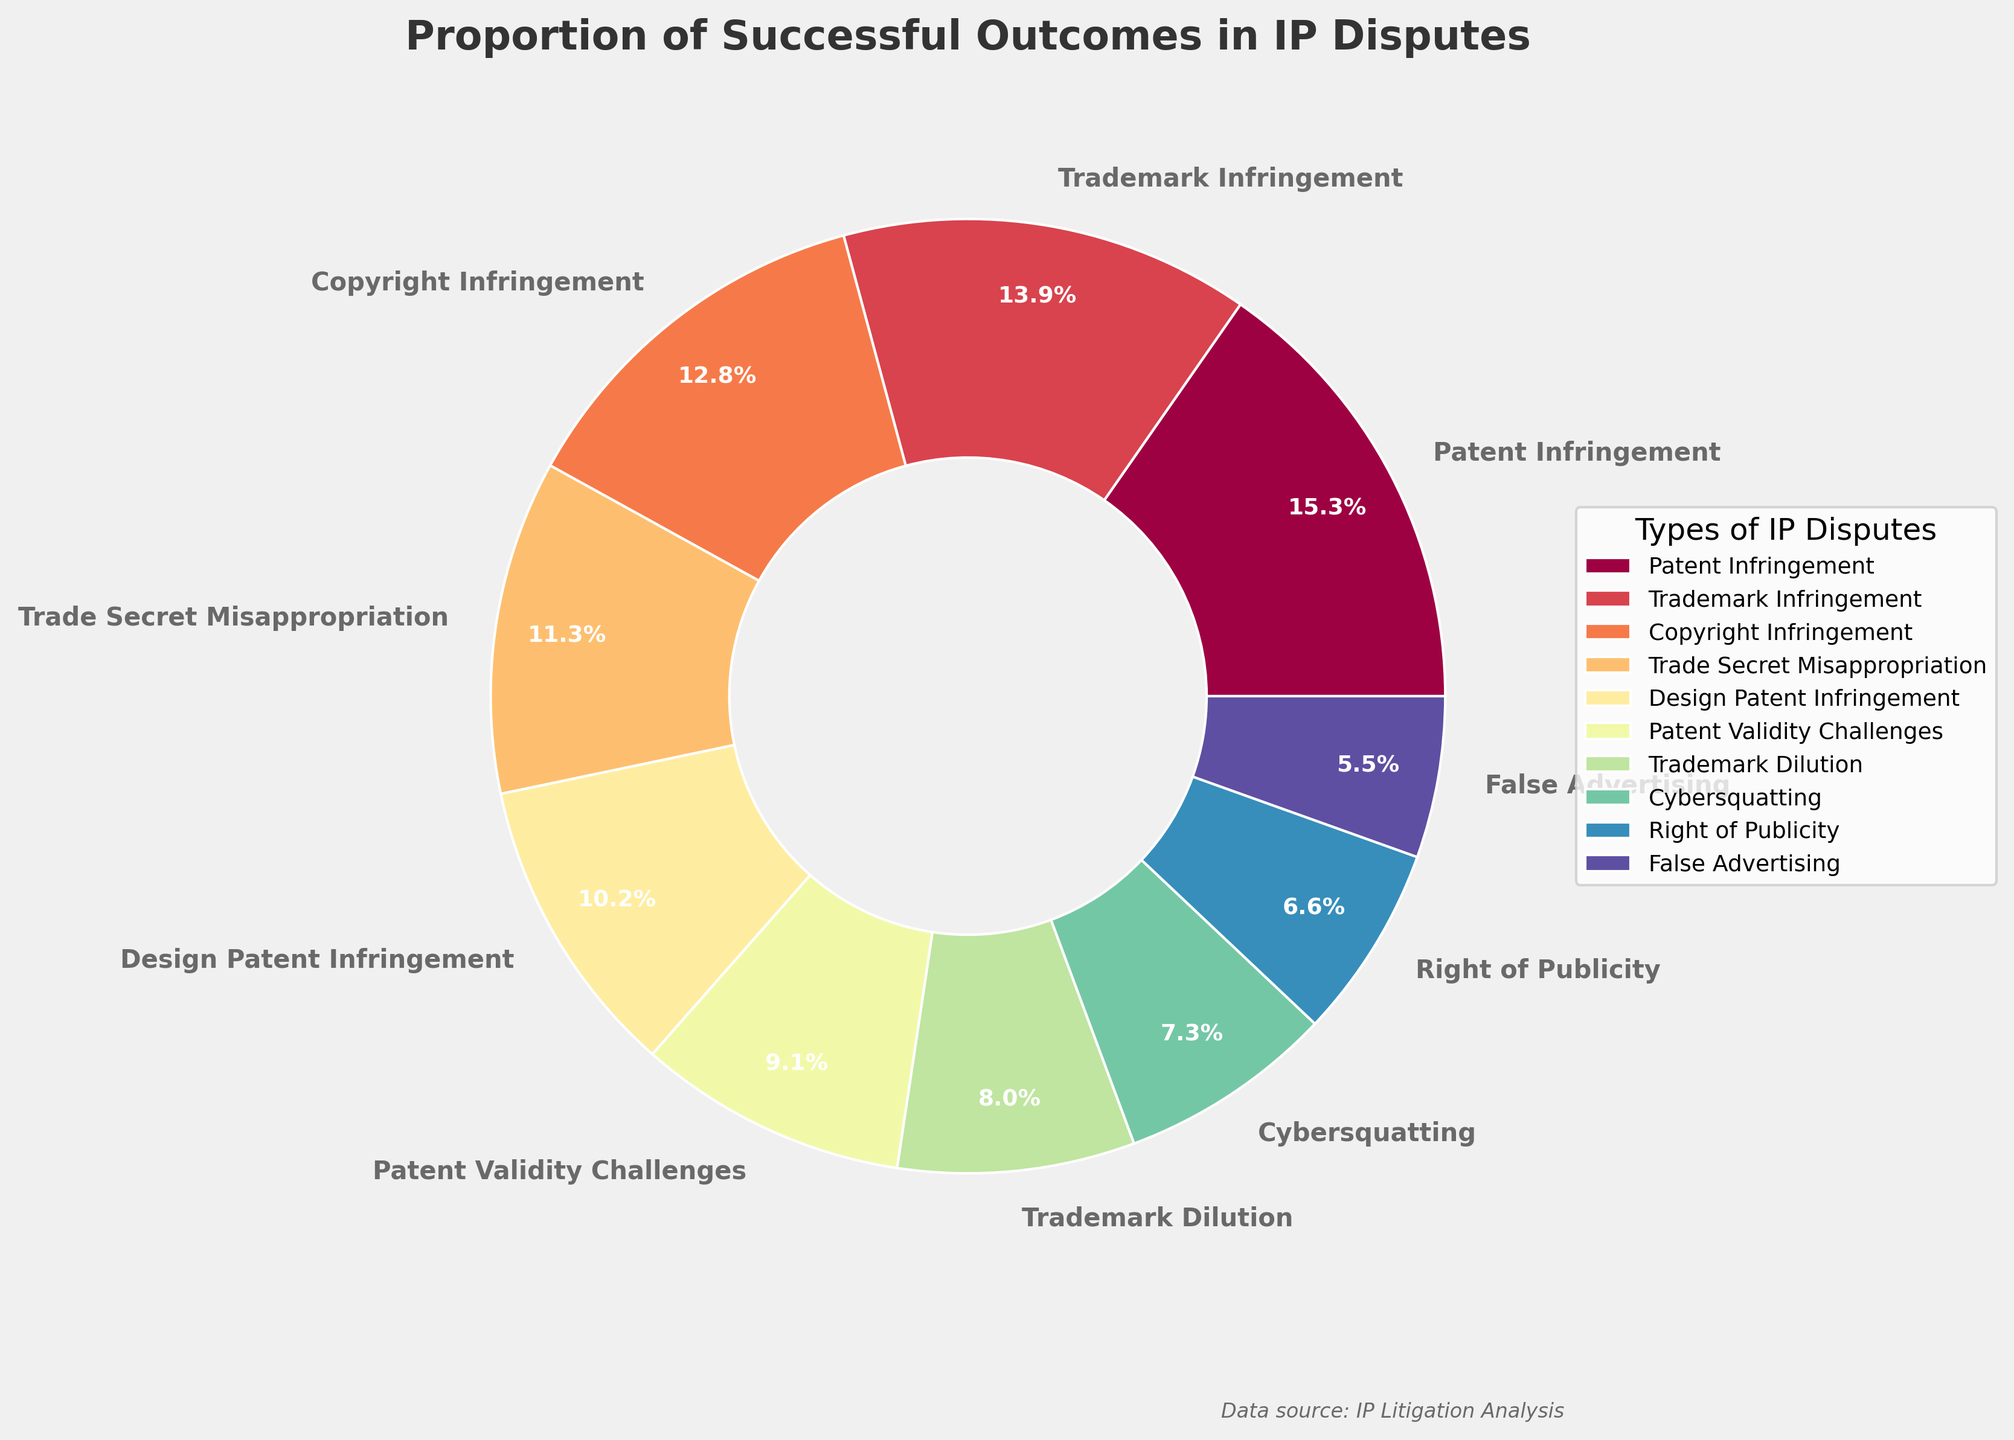What is the most prevalent type of IP dispute based on successful outcomes? To determine the most prevalent type of IP dispute based on successful outcomes, look for the segment with the largest percentage in the pie chart. The largest segment belongs to "Patent Infringement" at 42%.
Answer: Patent Infringement Which IP dispute has a higher success rate, Trade Secret Misappropriation or Trademark Dilution? Compare the percentages provided for Trade Secret Misappropriation (31%) and Trademark Dilution (22%). Trade Secret Misappropriation has a higher success rate.
Answer: Trade Secret Misappropriation What is the combined percentage of successful outcomes for Trademark Infringement and Copyright Infringement? Add the percentages for Trademark Infringement (38%) and Copyright Infringement (35%). The combined percentage is 38% + 35% = 73%.
Answer: 73% How does the success rate for Design Patent Infringement compare to that of Patent Infringement? Look at the percentages for Design Patent Infringement (28%) and Patent Infringement (42%). Patent Infringement has a higher success rate than Design Patent Infringement.
Answer: Patent Infringement has a higher success rate Which segment of the pie chart represents the lowest success rate in IP disputes? Identify the smallest segment in the pie chart with the lowest percentage. The smallest segment represents False Advertising with a success rate of 15%.
Answer: False Advertising Is the success rate for Cybersquatting higher or lower than the rate for Right of Publicity? Compare the percentages for Cybersquatting (20%) and Right of Publicity (18%). Cybersquatting has a higher success rate.
Answer: Cybersquatting What is the difference in success rates between Patent Validity Challenges and Trademark Dilution? Calculate the difference by subtracting the percentage for Trademark Dilution (22%) from Patent Validity Challenges (25%). The difference is 25% - 22% = 3%.
Answer: 3% Which type of IP dispute shares the same color spectrum as Patent Infringement in the pie chart? Observe the color spectrum used in the pie chart and identify the segments with similar colors. Since the chart uses a color gradient, Trademark Infringement and Copyright Infringement are close in color to Patent Infringement.
Answer: Trademark Infringement, Copyright Infringement 